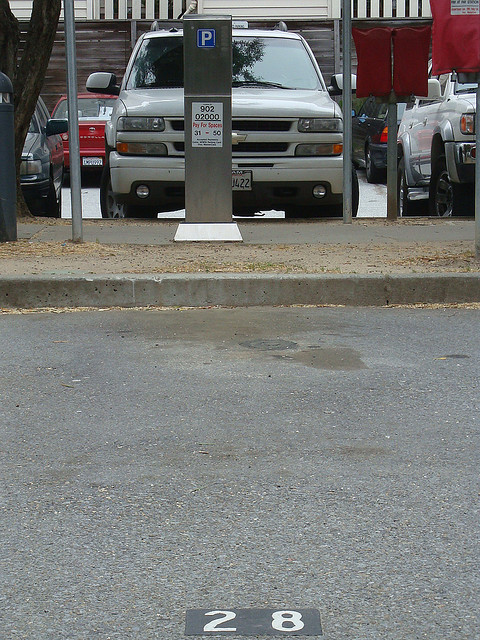Imagine what would happen if there was a significant event, like a parade, in this area. During a significant event such as a parade, the parking situation could become extremely hectic. Streets might be temporarily closed, further limiting available spaces while attracting a high volume of visitors. Local authorities would likely need to manage traffic flow and provide alternative parking solutions, such as designated event lots or increased public transport options, to manage the influx of vehicles. How might this affect local businesses? Local businesses could experience both positive and negative impacts. On one hand, the influx of visitors can lead to increased foot traffic and potential sales boosts. On the other hand, reduced parking availability might deter some regular customers, making it challenging for them to access businesses as they typically would. Strategic planning and communication of alternative parking solutions by businesses and authorities can help mitigate potential downsides. 